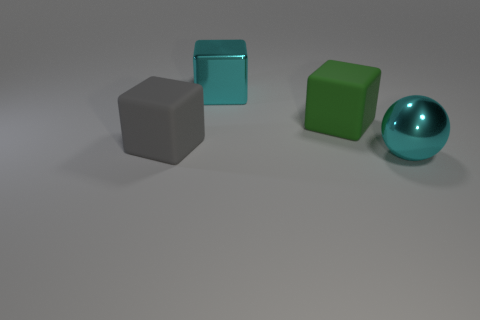Does the big metallic object that is on the left side of the large sphere have the same color as the metal sphere?
Your response must be concise. Yes. How many objects are red matte balls or large gray cubes?
Your response must be concise. 1. What number of other things are the same shape as the big gray thing?
Offer a very short reply. 2. How many other things are the same material as the big ball?
Provide a succinct answer. 1. There is another rubber thing that is the same shape as the large gray matte object; what is its size?
Your answer should be compact. Large. Does the big shiny ball have the same color as the big metal cube?
Give a very brief answer. Yes. The big thing that is both to the right of the big cyan block and behind the gray rubber cube is what color?
Your answer should be very brief. Green. How many things are either big matte objects that are right of the cyan cube or tiny matte spheres?
Your answer should be very brief. 1. The other matte object that is the same shape as the green rubber object is what color?
Your answer should be compact. Gray. There is a gray object; is it the same shape as the matte thing that is to the right of the cyan metallic cube?
Your answer should be very brief. Yes. 